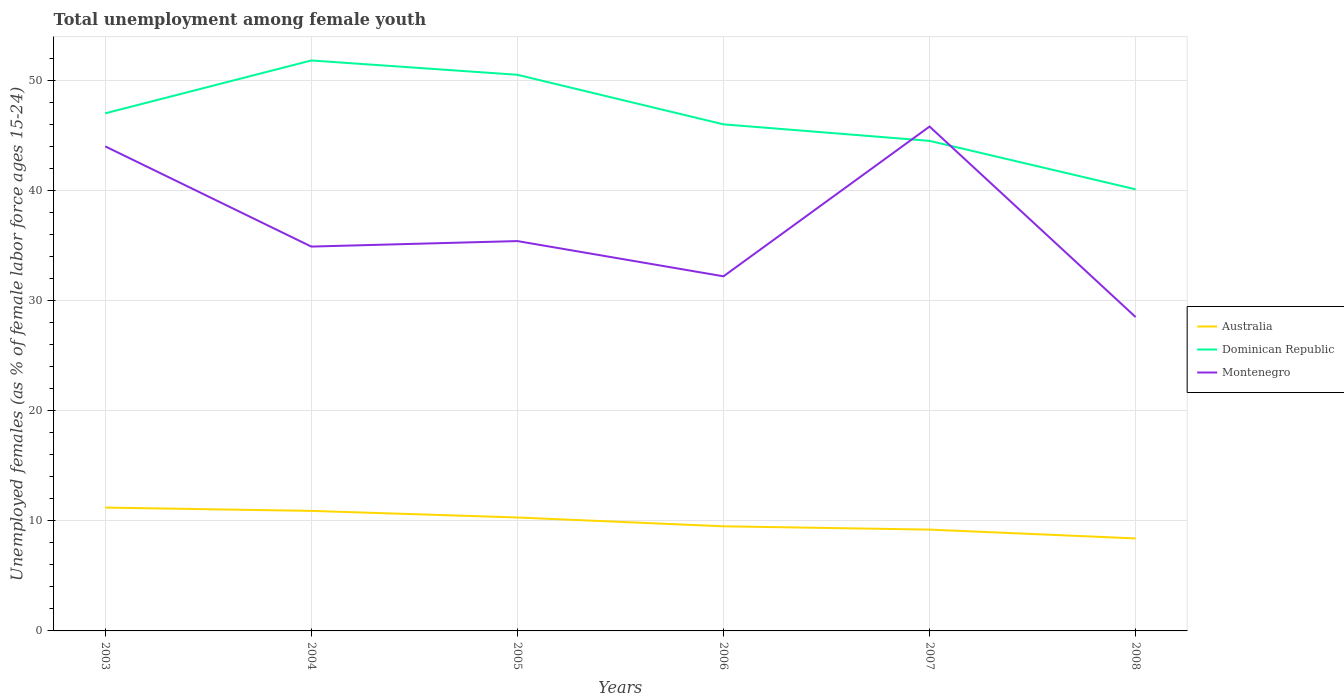How many different coloured lines are there?
Your answer should be compact. 3. Does the line corresponding to Montenegro intersect with the line corresponding to Australia?
Your response must be concise. No. Is the number of lines equal to the number of legend labels?
Your response must be concise. Yes. Across all years, what is the maximum percentage of unemployed females in in Dominican Republic?
Your response must be concise. 40.1. In which year was the percentage of unemployed females in in Dominican Republic maximum?
Provide a succinct answer. 2008. What is the total percentage of unemployed females in in Dominican Republic in the graph?
Offer a very short reply. 5.8. What is the difference between the highest and the second highest percentage of unemployed females in in Australia?
Provide a short and direct response. 2.8. Is the percentage of unemployed females in in Montenegro strictly greater than the percentage of unemployed females in in Dominican Republic over the years?
Your response must be concise. No. How many lines are there?
Provide a short and direct response. 3. How many years are there in the graph?
Your answer should be very brief. 6. What is the difference between two consecutive major ticks on the Y-axis?
Your response must be concise. 10. Are the values on the major ticks of Y-axis written in scientific E-notation?
Provide a short and direct response. No. Does the graph contain any zero values?
Your answer should be compact. No. How many legend labels are there?
Your answer should be compact. 3. How are the legend labels stacked?
Offer a very short reply. Vertical. What is the title of the graph?
Your response must be concise. Total unemployment among female youth. Does "Zambia" appear as one of the legend labels in the graph?
Ensure brevity in your answer.  No. What is the label or title of the Y-axis?
Offer a very short reply. Unemployed females (as % of female labor force ages 15-24). What is the Unemployed females (as % of female labor force ages 15-24) in Australia in 2003?
Offer a very short reply. 11.2. What is the Unemployed females (as % of female labor force ages 15-24) in Australia in 2004?
Give a very brief answer. 10.9. What is the Unemployed females (as % of female labor force ages 15-24) in Dominican Republic in 2004?
Offer a terse response. 51.8. What is the Unemployed females (as % of female labor force ages 15-24) in Montenegro in 2004?
Offer a very short reply. 34.9. What is the Unemployed females (as % of female labor force ages 15-24) of Australia in 2005?
Your answer should be compact. 10.3. What is the Unemployed females (as % of female labor force ages 15-24) of Dominican Republic in 2005?
Give a very brief answer. 50.5. What is the Unemployed females (as % of female labor force ages 15-24) in Montenegro in 2005?
Provide a succinct answer. 35.4. What is the Unemployed females (as % of female labor force ages 15-24) of Australia in 2006?
Your response must be concise. 9.5. What is the Unemployed females (as % of female labor force ages 15-24) in Montenegro in 2006?
Give a very brief answer. 32.2. What is the Unemployed females (as % of female labor force ages 15-24) of Australia in 2007?
Ensure brevity in your answer.  9.2. What is the Unemployed females (as % of female labor force ages 15-24) in Dominican Republic in 2007?
Give a very brief answer. 44.5. What is the Unemployed females (as % of female labor force ages 15-24) of Montenegro in 2007?
Offer a terse response. 45.8. What is the Unemployed females (as % of female labor force ages 15-24) of Australia in 2008?
Provide a short and direct response. 8.4. What is the Unemployed females (as % of female labor force ages 15-24) of Dominican Republic in 2008?
Make the answer very short. 40.1. Across all years, what is the maximum Unemployed females (as % of female labor force ages 15-24) of Australia?
Offer a terse response. 11.2. Across all years, what is the maximum Unemployed females (as % of female labor force ages 15-24) of Dominican Republic?
Your answer should be compact. 51.8. Across all years, what is the maximum Unemployed females (as % of female labor force ages 15-24) in Montenegro?
Make the answer very short. 45.8. Across all years, what is the minimum Unemployed females (as % of female labor force ages 15-24) of Australia?
Your answer should be very brief. 8.4. Across all years, what is the minimum Unemployed females (as % of female labor force ages 15-24) of Dominican Republic?
Your answer should be compact. 40.1. What is the total Unemployed females (as % of female labor force ages 15-24) in Australia in the graph?
Give a very brief answer. 59.5. What is the total Unemployed females (as % of female labor force ages 15-24) in Dominican Republic in the graph?
Offer a terse response. 279.9. What is the total Unemployed females (as % of female labor force ages 15-24) of Montenegro in the graph?
Your response must be concise. 220.8. What is the difference between the Unemployed females (as % of female labor force ages 15-24) of Dominican Republic in 2003 and that in 2004?
Offer a very short reply. -4.8. What is the difference between the Unemployed females (as % of female labor force ages 15-24) in Australia in 2003 and that in 2005?
Ensure brevity in your answer.  0.9. What is the difference between the Unemployed females (as % of female labor force ages 15-24) in Australia in 2003 and that in 2006?
Offer a terse response. 1.7. What is the difference between the Unemployed females (as % of female labor force ages 15-24) of Dominican Republic in 2003 and that in 2006?
Your answer should be compact. 1. What is the difference between the Unemployed females (as % of female labor force ages 15-24) in Montenegro in 2003 and that in 2007?
Provide a short and direct response. -1.8. What is the difference between the Unemployed females (as % of female labor force ages 15-24) in Dominican Republic in 2003 and that in 2008?
Your answer should be very brief. 6.9. What is the difference between the Unemployed females (as % of female labor force ages 15-24) of Dominican Republic in 2004 and that in 2005?
Provide a succinct answer. 1.3. What is the difference between the Unemployed females (as % of female labor force ages 15-24) in Australia in 2004 and that in 2006?
Offer a very short reply. 1.4. What is the difference between the Unemployed females (as % of female labor force ages 15-24) of Australia in 2004 and that in 2007?
Make the answer very short. 1.7. What is the difference between the Unemployed females (as % of female labor force ages 15-24) in Australia in 2004 and that in 2008?
Provide a short and direct response. 2.5. What is the difference between the Unemployed females (as % of female labor force ages 15-24) of Montenegro in 2004 and that in 2008?
Your response must be concise. 6.4. What is the difference between the Unemployed females (as % of female labor force ages 15-24) in Dominican Republic in 2005 and that in 2006?
Ensure brevity in your answer.  4.5. What is the difference between the Unemployed females (as % of female labor force ages 15-24) of Montenegro in 2005 and that in 2006?
Give a very brief answer. 3.2. What is the difference between the Unemployed females (as % of female labor force ages 15-24) of Australia in 2005 and that in 2007?
Your response must be concise. 1.1. What is the difference between the Unemployed females (as % of female labor force ages 15-24) in Montenegro in 2005 and that in 2008?
Make the answer very short. 6.9. What is the difference between the Unemployed females (as % of female labor force ages 15-24) in Australia in 2006 and that in 2007?
Keep it short and to the point. 0.3. What is the difference between the Unemployed females (as % of female labor force ages 15-24) of Dominican Republic in 2006 and that in 2007?
Ensure brevity in your answer.  1.5. What is the difference between the Unemployed females (as % of female labor force ages 15-24) in Australia in 2006 and that in 2008?
Offer a terse response. 1.1. What is the difference between the Unemployed females (as % of female labor force ages 15-24) of Montenegro in 2006 and that in 2008?
Provide a short and direct response. 3.7. What is the difference between the Unemployed females (as % of female labor force ages 15-24) in Montenegro in 2007 and that in 2008?
Keep it short and to the point. 17.3. What is the difference between the Unemployed females (as % of female labor force ages 15-24) of Australia in 2003 and the Unemployed females (as % of female labor force ages 15-24) of Dominican Republic in 2004?
Your answer should be very brief. -40.6. What is the difference between the Unemployed females (as % of female labor force ages 15-24) of Australia in 2003 and the Unemployed females (as % of female labor force ages 15-24) of Montenegro in 2004?
Keep it short and to the point. -23.7. What is the difference between the Unemployed females (as % of female labor force ages 15-24) of Australia in 2003 and the Unemployed females (as % of female labor force ages 15-24) of Dominican Republic in 2005?
Provide a succinct answer. -39.3. What is the difference between the Unemployed females (as % of female labor force ages 15-24) in Australia in 2003 and the Unemployed females (as % of female labor force ages 15-24) in Montenegro in 2005?
Provide a short and direct response. -24.2. What is the difference between the Unemployed females (as % of female labor force ages 15-24) in Australia in 2003 and the Unemployed females (as % of female labor force ages 15-24) in Dominican Republic in 2006?
Provide a short and direct response. -34.8. What is the difference between the Unemployed females (as % of female labor force ages 15-24) of Australia in 2003 and the Unemployed females (as % of female labor force ages 15-24) of Montenegro in 2006?
Ensure brevity in your answer.  -21. What is the difference between the Unemployed females (as % of female labor force ages 15-24) of Dominican Republic in 2003 and the Unemployed females (as % of female labor force ages 15-24) of Montenegro in 2006?
Your response must be concise. 14.8. What is the difference between the Unemployed females (as % of female labor force ages 15-24) in Australia in 2003 and the Unemployed females (as % of female labor force ages 15-24) in Dominican Republic in 2007?
Make the answer very short. -33.3. What is the difference between the Unemployed females (as % of female labor force ages 15-24) of Australia in 2003 and the Unemployed females (as % of female labor force ages 15-24) of Montenegro in 2007?
Keep it short and to the point. -34.6. What is the difference between the Unemployed females (as % of female labor force ages 15-24) of Dominican Republic in 2003 and the Unemployed females (as % of female labor force ages 15-24) of Montenegro in 2007?
Provide a succinct answer. 1.2. What is the difference between the Unemployed females (as % of female labor force ages 15-24) in Australia in 2003 and the Unemployed females (as % of female labor force ages 15-24) in Dominican Republic in 2008?
Offer a terse response. -28.9. What is the difference between the Unemployed females (as % of female labor force ages 15-24) of Australia in 2003 and the Unemployed females (as % of female labor force ages 15-24) of Montenegro in 2008?
Offer a terse response. -17.3. What is the difference between the Unemployed females (as % of female labor force ages 15-24) of Dominican Republic in 2003 and the Unemployed females (as % of female labor force ages 15-24) of Montenegro in 2008?
Make the answer very short. 18.5. What is the difference between the Unemployed females (as % of female labor force ages 15-24) of Australia in 2004 and the Unemployed females (as % of female labor force ages 15-24) of Dominican Republic in 2005?
Make the answer very short. -39.6. What is the difference between the Unemployed females (as % of female labor force ages 15-24) of Australia in 2004 and the Unemployed females (as % of female labor force ages 15-24) of Montenegro in 2005?
Your response must be concise. -24.5. What is the difference between the Unemployed females (as % of female labor force ages 15-24) of Dominican Republic in 2004 and the Unemployed females (as % of female labor force ages 15-24) of Montenegro in 2005?
Your answer should be compact. 16.4. What is the difference between the Unemployed females (as % of female labor force ages 15-24) of Australia in 2004 and the Unemployed females (as % of female labor force ages 15-24) of Dominican Republic in 2006?
Give a very brief answer. -35.1. What is the difference between the Unemployed females (as % of female labor force ages 15-24) of Australia in 2004 and the Unemployed females (as % of female labor force ages 15-24) of Montenegro in 2006?
Offer a very short reply. -21.3. What is the difference between the Unemployed females (as % of female labor force ages 15-24) in Dominican Republic in 2004 and the Unemployed females (as % of female labor force ages 15-24) in Montenegro in 2006?
Give a very brief answer. 19.6. What is the difference between the Unemployed females (as % of female labor force ages 15-24) of Australia in 2004 and the Unemployed females (as % of female labor force ages 15-24) of Dominican Republic in 2007?
Keep it short and to the point. -33.6. What is the difference between the Unemployed females (as % of female labor force ages 15-24) in Australia in 2004 and the Unemployed females (as % of female labor force ages 15-24) in Montenegro in 2007?
Your answer should be compact. -34.9. What is the difference between the Unemployed females (as % of female labor force ages 15-24) of Australia in 2004 and the Unemployed females (as % of female labor force ages 15-24) of Dominican Republic in 2008?
Give a very brief answer. -29.2. What is the difference between the Unemployed females (as % of female labor force ages 15-24) of Australia in 2004 and the Unemployed females (as % of female labor force ages 15-24) of Montenegro in 2008?
Provide a succinct answer. -17.6. What is the difference between the Unemployed females (as % of female labor force ages 15-24) in Dominican Republic in 2004 and the Unemployed females (as % of female labor force ages 15-24) in Montenegro in 2008?
Provide a short and direct response. 23.3. What is the difference between the Unemployed females (as % of female labor force ages 15-24) in Australia in 2005 and the Unemployed females (as % of female labor force ages 15-24) in Dominican Republic in 2006?
Your answer should be very brief. -35.7. What is the difference between the Unemployed females (as % of female labor force ages 15-24) of Australia in 2005 and the Unemployed females (as % of female labor force ages 15-24) of Montenegro in 2006?
Your answer should be compact. -21.9. What is the difference between the Unemployed females (as % of female labor force ages 15-24) of Dominican Republic in 2005 and the Unemployed females (as % of female labor force ages 15-24) of Montenegro in 2006?
Offer a very short reply. 18.3. What is the difference between the Unemployed females (as % of female labor force ages 15-24) in Australia in 2005 and the Unemployed females (as % of female labor force ages 15-24) in Dominican Republic in 2007?
Your response must be concise. -34.2. What is the difference between the Unemployed females (as % of female labor force ages 15-24) of Australia in 2005 and the Unemployed females (as % of female labor force ages 15-24) of Montenegro in 2007?
Offer a terse response. -35.5. What is the difference between the Unemployed females (as % of female labor force ages 15-24) in Australia in 2005 and the Unemployed females (as % of female labor force ages 15-24) in Dominican Republic in 2008?
Provide a short and direct response. -29.8. What is the difference between the Unemployed females (as % of female labor force ages 15-24) in Australia in 2005 and the Unemployed females (as % of female labor force ages 15-24) in Montenegro in 2008?
Offer a very short reply. -18.2. What is the difference between the Unemployed females (as % of female labor force ages 15-24) in Dominican Republic in 2005 and the Unemployed females (as % of female labor force ages 15-24) in Montenegro in 2008?
Make the answer very short. 22. What is the difference between the Unemployed females (as % of female labor force ages 15-24) of Australia in 2006 and the Unemployed females (as % of female labor force ages 15-24) of Dominican Republic in 2007?
Keep it short and to the point. -35. What is the difference between the Unemployed females (as % of female labor force ages 15-24) of Australia in 2006 and the Unemployed females (as % of female labor force ages 15-24) of Montenegro in 2007?
Provide a succinct answer. -36.3. What is the difference between the Unemployed females (as % of female labor force ages 15-24) of Dominican Republic in 2006 and the Unemployed females (as % of female labor force ages 15-24) of Montenegro in 2007?
Your response must be concise. 0.2. What is the difference between the Unemployed females (as % of female labor force ages 15-24) of Australia in 2006 and the Unemployed females (as % of female labor force ages 15-24) of Dominican Republic in 2008?
Your answer should be very brief. -30.6. What is the difference between the Unemployed females (as % of female labor force ages 15-24) of Dominican Republic in 2006 and the Unemployed females (as % of female labor force ages 15-24) of Montenegro in 2008?
Your answer should be compact. 17.5. What is the difference between the Unemployed females (as % of female labor force ages 15-24) of Australia in 2007 and the Unemployed females (as % of female labor force ages 15-24) of Dominican Republic in 2008?
Ensure brevity in your answer.  -30.9. What is the difference between the Unemployed females (as % of female labor force ages 15-24) of Australia in 2007 and the Unemployed females (as % of female labor force ages 15-24) of Montenegro in 2008?
Provide a succinct answer. -19.3. What is the difference between the Unemployed females (as % of female labor force ages 15-24) of Dominican Republic in 2007 and the Unemployed females (as % of female labor force ages 15-24) of Montenegro in 2008?
Your answer should be very brief. 16. What is the average Unemployed females (as % of female labor force ages 15-24) in Australia per year?
Make the answer very short. 9.92. What is the average Unemployed females (as % of female labor force ages 15-24) in Dominican Republic per year?
Give a very brief answer. 46.65. What is the average Unemployed females (as % of female labor force ages 15-24) in Montenegro per year?
Provide a short and direct response. 36.8. In the year 2003, what is the difference between the Unemployed females (as % of female labor force ages 15-24) in Australia and Unemployed females (as % of female labor force ages 15-24) in Dominican Republic?
Provide a succinct answer. -35.8. In the year 2003, what is the difference between the Unemployed females (as % of female labor force ages 15-24) in Australia and Unemployed females (as % of female labor force ages 15-24) in Montenegro?
Provide a short and direct response. -32.8. In the year 2003, what is the difference between the Unemployed females (as % of female labor force ages 15-24) of Dominican Republic and Unemployed females (as % of female labor force ages 15-24) of Montenegro?
Offer a terse response. 3. In the year 2004, what is the difference between the Unemployed females (as % of female labor force ages 15-24) of Australia and Unemployed females (as % of female labor force ages 15-24) of Dominican Republic?
Your answer should be very brief. -40.9. In the year 2005, what is the difference between the Unemployed females (as % of female labor force ages 15-24) of Australia and Unemployed females (as % of female labor force ages 15-24) of Dominican Republic?
Offer a very short reply. -40.2. In the year 2005, what is the difference between the Unemployed females (as % of female labor force ages 15-24) of Australia and Unemployed females (as % of female labor force ages 15-24) of Montenegro?
Offer a very short reply. -25.1. In the year 2006, what is the difference between the Unemployed females (as % of female labor force ages 15-24) in Australia and Unemployed females (as % of female labor force ages 15-24) in Dominican Republic?
Your response must be concise. -36.5. In the year 2006, what is the difference between the Unemployed females (as % of female labor force ages 15-24) in Australia and Unemployed females (as % of female labor force ages 15-24) in Montenegro?
Keep it short and to the point. -22.7. In the year 2007, what is the difference between the Unemployed females (as % of female labor force ages 15-24) of Australia and Unemployed females (as % of female labor force ages 15-24) of Dominican Republic?
Your answer should be compact. -35.3. In the year 2007, what is the difference between the Unemployed females (as % of female labor force ages 15-24) in Australia and Unemployed females (as % of female labor force ages 15-24) in Montenegro?
Ensure brevity in your answer.  -36.6. In the year 2007, what is the difference between the Unemployed females (as % of female labor force ages 15-24) in Dominican Republic and Unemployed females (as % of female labor force ages 15-24) in Montenegro?
Make the answer very short. -1.3. In the year 2008, what is the difference between the Unemployed females (as % of female labor force ages 15-24) of Australia and Unemployed females (as % of female labor force ages 15-24) of Dominican Republic?
Make the answer very short. -31.7. In the year 2008, what is the difference between the Unemployed females (as % of female labor force ages 15-24) of Australia and Unemployed females (as % of female labor force ages 15-24) of Montenegro?
Your response must be concise. -20.1. What is the ratio of the Unemployed females (as % of female labor force ages 15-24) of Australia in 2003 to that in 2004?
Ensure brevity in your answer.  1.03. What is the ratio of the Unemployed females (as % of female labor force ages 15-24) of Dominican Republic in 2003 to that in 2004?
Offer a very short reply. 0.91. What is the ratio of the Unemployed females (as % of female labor force ages 15-24) in Montenegro in 2003 to that in 2004?
Your answer should be compact. 1.26. What is the ratio of the Unemployed females (as % of female labor force ages 15-24) of Australia in 2003 to that in 2005?
Keep it short and to the point. 1.09. What is the ratio of the Unemployed females (as % of female labor force ages 15-24) in Dominican Republic in 2003 to that in 2005?
Your answer should be compact. 0.93. What is the ratio of the Unemployed females (as % of female labor force ages 15-24) in Montenegro in 2003 to that in 2005?
Give a very brief answer. 1.24. What is the ratio of the Unemployed females (as % of female labor force ages 15-24) of Australia in 2003 to that in 2006?
Offer a very short reply. 1.18. What is the ratio of the Unemployed females (as % of female labor force ages 15-24) of Dominican Republic in 2003 to that in 2006?
Your answer should be very brief. 1.02. What is the ratio of the Unemployed females (as % of female labor force ages 15-24) in Montenegro in 2003 to that in 2006?
Offer a very short reply. 1.37. What is the ratio of the Unemployed females (as % of female labor force ages 15-24) of Australia in 2003 to that in 2007?
Offer a very short reply. 1.22. What is the ratio of the Unemployed females (as % of female labor force ages 15-24) of Dominican Republic in 2003 to that in 2007?
Provide a short and direct response. 1.06. What is the ratio of the Unemployed females (as % of female labor force ages 15-24) in Montenegro in 2003 to that in 2007?
Ensure brevity in your answer.  0.96. What is the ratio of the Unemployed females (as % of female labor force ages 15-24) in Australia in 2003 to that in 2008?
Give a very brief answer. 1.33. What is the ratio of the Unemployed females (as % of female labor force ages 15-24) in Dominican Republic in 2003 to that in 2008?
Your response must be concise. 1.17. What is the ratio of the Unemployed females (as % of female labor force ages 15-24) of Montenegro in 2003 to that in 2008?
Your answer should be compact. 1.54. What is the ratio of the Unemployed females (as % of female labor force ages 15-24) of Australia in 2004 to that in 2005?
Ensure brevity in your answer.  1.06. What is the ratio of the Unemployed females (as % of female labor force ages 15-24) in Dominican Republic in 2004 to that in 2005?
Provide a succinct answer. 1.03. What is the ratio of the Unemployed females (as % of female labor force ages 15-24) in Montenegro in 2004 to that in 2005?
Your answer should be compact. 0.99. What is the ratio of the Unemployed females (as % of female labor force ages 15-24) of Australia in 2004 to that in 2006?
Offer a very short reply. 1.15. What is the ratio of the Unemployed females (as % of female labor force ages 15-24) in Dominican Republic in 2004 to that in 2006?
Give a very brief answer. 1.13. What is the ratio of the Unemployed females (as % of female labor force ages 15-24) of Montenegro in 2004 to that in 2006?
Keep it short and to the point. 1.08. What is the ratio of the Unemployed females (as % of female labor force ages 15-24) of Australia in 2004 to that in 2007?
Give a very brief answer. 1.18. What is the ratio of the Unemployed females (as % of female labor force ages 15-24) of Dominican Republic in 2004 to that in 2007?
Offer a terse response. 1.16. What is the ratio of the Unemployed females (as % of female labor force ages 15-24) in Montenegro in 2004 to that in 2007?
Your answer should be compact. 0.76. What is the ratio of the Unemployed females (as % of female labor force ages 15-24) of Australia in 2004 to that in 2008?
Provide a succinct answer. 1.3. What is the ratio of the Unemployed females (as % of female labor force ages 15-24) of Dominican Republic in 2004 to that in 2008?
Make the answer very short. 1.29. What is the ratio of the Unemployed females (as % of female labor force ages 15-24) in Montenegro in 2004 to that in 2008?
Your answer should be compact. 1.22. What is the ratio of the Unemployed females (as % of female labor force ages 15-24) in Australia in 2005 to that in 2006?
Offer a terse response. 1.08. What is the ratio of the Unemployed females (as % of female labor force ages 15-24) of Dominican Republic in 2005 to that in 2006?
Your answer should be compact. 1.1. What is the ratio of the Unemployed females (as % of female labor force ages 15-24) in Montenegro in 2005 to that in 2006?
Keep it short and to the point. 1.1. What is the ratio of the Unemployed females (as % of female labor force ages 15-24) of Australia in 2005 to that in 2007?
Make the answer very short. 1.12. What is the ratio of the Unemployed females (as % of female labor force ages 15-24) of Dominican Republic in 2005 to that in 2007?
Make the answer very short. 1.13. What is the ratio of the Unemployed females (as % of female labor force ages 15-24) in Montenegro in 2005 to that in 2007?
Offer a terse response. 0.77. What is the ratio of the Unemployed females (as % of female labor force ages 15-24) in Australia in 2005 to that in 2008?
Offer a terse response. 1.23. What is the ratio of the Unemployed females (as % of female labor force ages 15-24) in Dominican Republic in 2005 to that in 2008?
Offer a very short reply. 1.26. What is the ratio of the Unemployed females (as % of female labor force ages 15-24) in Montenegro in 2005 to that in 2008?
Offer a terse response. 1.24. What is the ratio of the Unemployed females (as % of female labor force ages 15-24) in Australia in 2006 to that in 2007?
Provide a short and direct response. 1.03. What is the ratio of the Unemployed females (as % of female labor force ages 15-24) in Dominican Republic in 2006 to that in 2007?
Offer a very short reply. 1.03. What is the ratio of the Unemployed females (as % of female labor force ages 15-24) in Montenegro in 2006 to that in 2007?
Your response must be concise. 0.7. What is the ratio of the Unemployed females (as % of female labor force ages 15-24) in Australia in 2006 to that in 2008?
Your response must be concise. 1.13. What is the ratio of the Unemployed females (as % of female labor force ages 15-24) in Dominican Republic in 2006 to that in 2008?
Your response must be concise. 1.15. What is the ratio of the Unemployed females (as % of female labor force ages 15-24) of Montenegro in 2006 to that in 2008?
Offer a terse response. 1.13. What is the ratio of the Unemployed females (as % of female labor force ages 15-24) of Australia in 2007 to that in 2008?
Keep it short and to the point. 1.1. What is the ratio of the Unemployed females (as % of female labor force ages 15-24) of Dominican Republic in 2007 to that in 2008?
Provide a succinct answer. 1.11. What is the ratio of the Unemployed females (as % of female labor force ages 15-24) of Montenegro in 2007 to that in 2008?
Your answer should be compact. 1.61. What is the difference between the highest and the second highest Unemployed females (as % of female labor force ages 15-24) in Montenegro?
Provide a short and direct response. 1.8. What is the difference between the highest and the lowest Unemployed females (as % of female labor force ages 15-24) in Montenegro?
Offer a terse response. 17.3. 